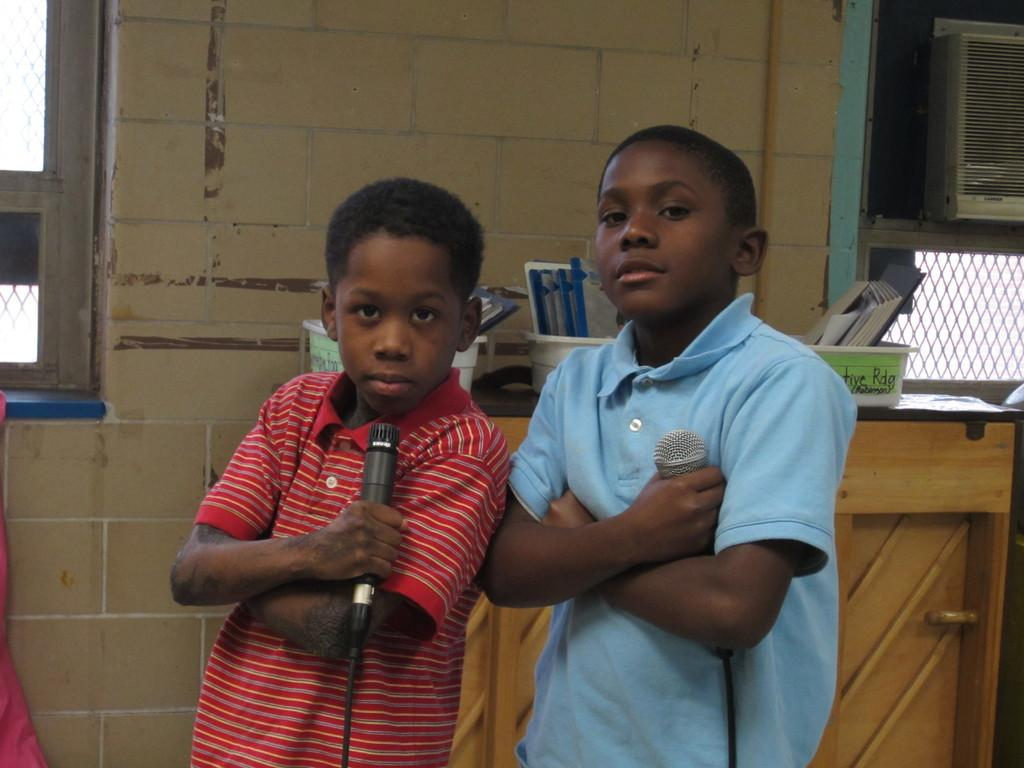How many kids are present in the image? There are two kids in the image. What are the kids doing in the image? The kids are standing and holding a mic in their hands. What type of silk is draped over the kids' legs in the image? There is no silk present in the image, nor is it draped over the kids' legs. 